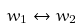Convert formula to latex. <formula><loc_0><loc_0><loc_500><loc_500>w _ { 1 } \leftrightarrow w _ { 2 }</formula> 